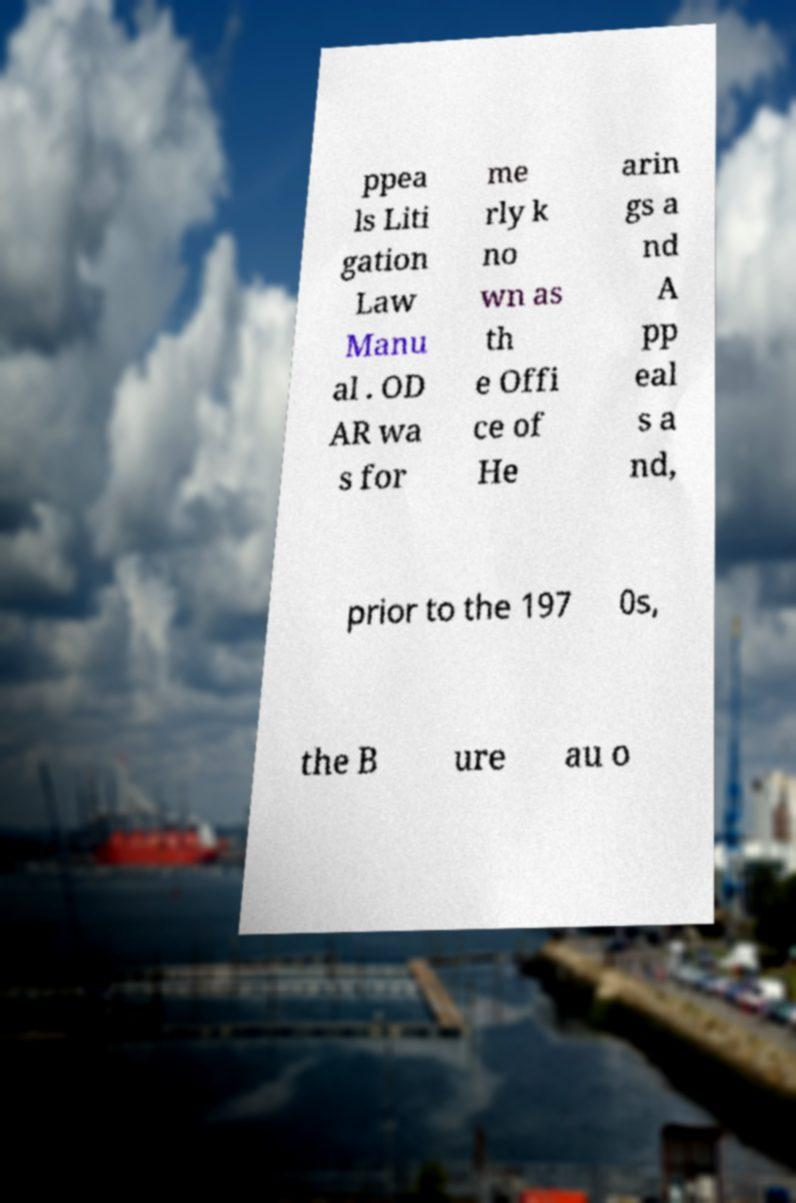Can you read and provide the text displayed in the image?This photo seems to have some interesting text. Can you extract and type it out for me? ppea ls Liti gation Law Manu al . OD AR wa s for me rly k no wn as th e Offi ce of He arin gs a nd A pp eal s a nd, prior to the 197 0s, the B ure au o 